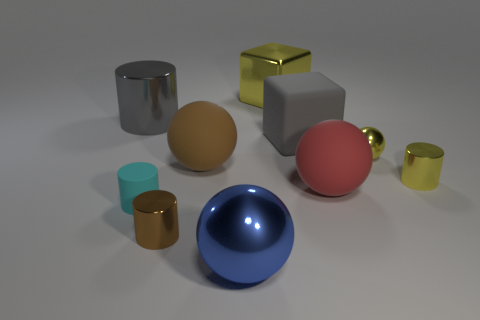Does the yellow metal cylinder have the same size as the metallic ball that is to the right of the large yellow thing?
Provide a short and direct response. Yes. Do the rubber ball that is to the left of the gray cube and the gray shiny cylinder have the same size?
Your answer should be very brief. Yes. What number of other objects are the same material as the yellow cylinder?
Provide a succinct answer. 5. Are there the same number of blue metal balls on the left side of the large brown sphere and small shiny balls right of the tiny cyan object?
Provide a succinct answer. No. There is a large shiny thing that is on the left side of the metal sphere that is on the left side of the tiny yellow metal object that is on the left side of the tiny yellow cylinder; what color is it?
Your answer should be very brief. Gray. What shape is the big metallic object that is to the left of the tiny brown metal thing?
Give a very brief answer. Cylinder. There is a brown thing that is made of the same material as the large cylinder; what is its shape?
Your response must be concise. Cylinder. Are there any other things that have the same shape as the tiny cyan rubber thing?
Provide a short and direct response. Yes. What number of yellow metallic things are to the right of the tiny sphere?
Offer a terse response. 1. Is the number of big objects that are on the left side of the cyan rubber object the same as the number of red balls?
Offer a terse response. Yes. 